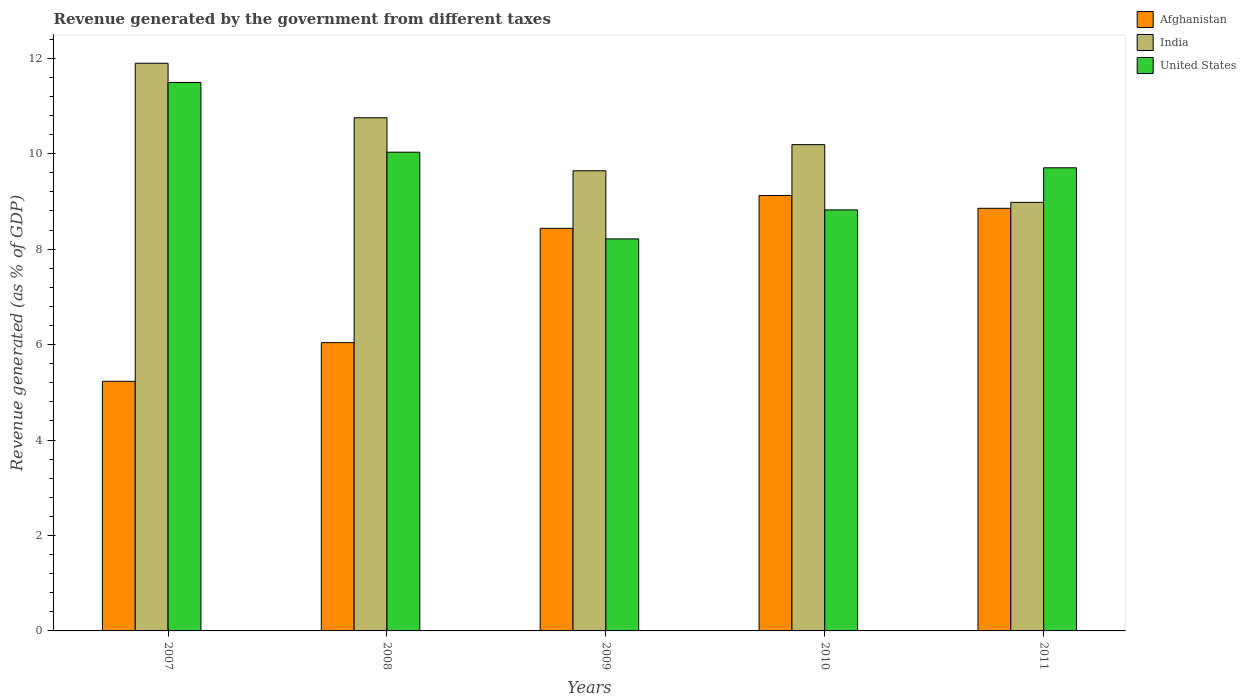How many different coloured bars are there?
Your response must be concise. 3. How many groups of bars are there?
Ensure brevity in your answer.  5. How many bars are there on the 2nd tick from the left?
Make the answer very short. 3. How many bars are there on the 1st tick from the right?
Provide a short and direct response. 3. What is the label of the 2nd group of bars from the left?
Offer a very short reply. 2008. In how many cases, is the number of bars for a given year not equal to the number of legend labels?
Make the answer very short. 0. What is the revenue generated by the government in Afghanistan in 2011?
Make the answer very short. 8.85. Across all years, what is the maximum revenue generated by the government in India?
Your answer should be very brief. 11.89. Across all years, what is the minimum revenue generated by the government in United States?
Provide a succinct answer. 8.21. What is the total revenue generated by the government in Afghanistan in the graph?
Provide a succinct answer. 37.68. What is the difference between the revenue generated by the government in United States in 2008 and that in 2009?
Your answer should be compact. 1.82. What is the difference between the revenue generated by the government in United States in 2008 and the revenue generated by the government in India in 2009?
Give a very brief answer. 0.39. What is the average revenue generated by the government in India per year?
Keep it short and to the point. 10.29. In the year 2010, what is the difference between the revenue generated by the government in Afghanistan and revenue generated by the government in India?
Keep it short and to the point. -1.06. What is the ratio of the revenue generated by the government in Afghanistan in 2010 to that in 2011?
Offer a very short reply. 1.03. Is the revenue generated by the government in Afghanistan in 2007 less than that in 2011?
Make the answer very short. Yes. Is the difference between the revenue generated by the government in Afghanistan in 2007 and 2009 greater than the difference between the revenue generated by the government in India in 2007 and 2009?
Offer a terse response. No. What is the difference between the highest and the second highest revenue generated by the government in Afghanistan?
Ensure brevity in your answer.  0.27. What is the difference between the highest and the lowest revenue generated by the government in Afghanistan?
Offer a very short reply. 3.89. Is it the case that in every year, the sum of the revenue generated by the government in United States and revenue generated by the government in India is greater than the revenue generated by the government in Afghanistan?
Provide a short and direct response. Yes. How many bars are there?
Keep it short and to the point. 15. How many years are there in the graph?
Provide a succinct answer. 5. Does the graph contain any zero values?
Ensure brevity in your answer.  No. Does the graph contain grids?
Provide a short and direct response. No. How are the legend labels stacked?
Your response must be concise. Vertical. What is the title of the graph?
Make the answer very short. Revenue generated by the government from different taxes. What is the label or title of the Y-axis?
Make the answer very short. Revenue generated (as % of GDP). What is the Revenue generated (as % of GDP) in Afghanistan in 2007?
Ensure brevity in your answer.  5.23. What is the Revenue generated (as % of GDP) of India in 2007?
Your answer should be compact. 11.89. What is the Revenue generated (as % of GDP) of United States in 2007?
Make the answer very short. 11.49. What is the Revenue generated (as % of GDP) of Afghanistan in 2008?
Give a very brief answer. 6.04. What is the Revenue generated (as % of GDP) of India in 2008?
Make the answer very short. 10.75. What is the Revenue generated (as % of GDP) in United States in 2008?
Provide a succinct answer. 10.03. What is the Revenue generated (as % of GDP) of Afghanistan in 2009?
Ensure brevity in your answer.  8.43. What is the Revenue generated (as % of GDP) in India in 2009?
Your answer should be very brief. 9.64. What is the Revenue generated (as % of GDP) in United States in 2009?
Your answer should be very brief. 8.21. What is the Revenue generated (as % of GDP) in Afghanistan in 2010?
Offer a terse response. 9.12. What is the Revenue generated (as % of GDP) of India in 2010?
Provide a succinct answer. 10.19. What is the Revenue generated (as % of GDP) in United States in 2010?
Offer a terse response. 8.82. What is the Revenue generated (as % of GDP) of Afghanistan in 2011?
Offer a terse response. 8.85. What is the Revenue generated (as % of GDP) of India in 2011?
Keep it short and to the point. 8.98. What is the Revenue generated (as % of GDP) in United States in 2011?
Offer a very short reply. 9.7. Across all years, what is the maximum Revenue generated (as % of GDP) of Afghanistan?
Provide a short and direct response. 9.12. Across all years, what is the maximum Revenue generated (as % of GDP) in India?
Make the answer very short. 11.89. Across all years, what is the maximum Revenue generated (as % of GDP) of United States?
Your response must be concise. 11.49. Across all years, what is the minimum Revenue generated (as % of GDP) of Afghanistan?
Your answer should be very brief. 5.23. Across all years, what is the minimum Revenue generated (as % of GDP) of India?
Your response must be concise. 8.98. Across all years, what is the minimum Revenue generated (as % of GDP) of United States?
Provide a succinct answer. 8.21. What is the total Revenue generated (as % of GDP) in Afghanistan in the graph?
Offer a terse response. 37.68. What is the total Revenue generated (as % of GDP) of India in the graph?
Make the answer very short. 51.45. What is the total Revenue generated (as % of GDP) in United States in the graph?
Ensure brevity in your answer.  48.26. What is the difference between the Revenue generated (as % of GDP) in Afghanistan in 2007 and that in 2008?
Your answer should be very brief. -0.81. What is the difference between the Revenue generated (as % of GDP) of India in 2007 and that in 2008?
Provide a short and direct response. 1.14. What is the difference between the Revenue generated (as % of GDP) in United States in 2007 and that in 2008?
Give a very brief answer. 1.46. What is the difference between the Revenue generated (as % of GDP) of Afghanistan in 2007 and that in 2009?
Ensure brevity in your answer.  -3.21. What is the difference between the Revenue generated (as % of GDP) of India in 2007 and that in 2009?
Provide a short and direct response. 2.25. What is the difference between the Revenue generated (as % of GDP) in United States in 2007 and that in 2009?
Give a very brief answer. 3.28. What is the difference between the Revenue generated (as % of GDP) of Afghanistan in 2007 and that in 2010?
Provide a short and direct response. -3.89. What is the difference between the Revenue generated (as % of GDP) of India in 2007 and that in 2010?
Give a very brief answer. 1.71. What is the difference between the Revenue generated (as % of GDP) in United States in 2007 and that in 2010?
Provide a short and direct response. 2.67. What is the difference between the Revenue generated (as % of GDP) in Afghanistan in 2007 and that in 2011?
Give a very brief answer. -3.62. What is the difference between the Revenue generated (as % of GDP) of India in 2007 and that in 2011?
Give a very brief answer. 2.91. What is the difference between the Revenue generated (as % of GDP) of United States in 2007 and that in 2011?
Give a very brief answer. 1.79. What is the difference between the Revenue generated (as % of GDP) in Afghanistan in 2008 and that in 2009?
Offer a terse response. -2.4. What is the difference between the Revenue generated (as % of GDP) of India in 2008 and that in 2009?
Your response must be concise. 1.11. What is the difference between the Revenue generated (as % of GDP) of United States in 2008 and that in 2009?
Your answer should be very brief. 1.82. What is the difference between the Revenue generated (as % of GDP) in Afghanistan in 2008 and that in 2010?
Your answer should be compact. -3.08. What is the difference between the Revenue generated (as % of GDP) in India in 2008 and that in 2010?
Offer a terse response. 0.56. What is the difference between the Revenue generated (as % of GDP) of United States in 2008 and that in 2010?
Provide a succinct answer. 1.21. What is the difference between the Revenue generated (as % of GDP) in Afghanistan in 2008 and that in 2011?
Make the answer very short. -2.82. What is the difference between the Revenue generated (as % of GDP) of India in 2008 and that in 2011?
Your answer should be compact. 1.77. What is the difference between the Revenue generated (as % of GDP) in United States in 2008 and that in 2011?
Give a very brief answer. 0.33. What is the difference between the Revenue generated (as % of GDP) in Afghanistan in 2009 and that in 2010?
Keep it short and to the point. -0.69. What is the difference between the Revenue generated (as % of GDP) in India in 2009 and that in 2010?
Your answer should be compact. -0.55. What is the difference between the Revenue generated (as % of GDP) of United States in 2009 and that in 2010?
Your answer should be very brief. -0.61. What is the difference between the Revenue generated (as % of GDP) in Afghanistan in 2009 and that in 2011?
Offer a very short reply. -0.42. What is the difference between the Revenue generated (as % of GDP) of India in 2009 and that in 2011?
Keep it short and to the point. 0.66. What is the difference between the Revenue generated (as % of GDP) of United States in 2009 and that in 2011?
Provide a succinct answer. -1.49. What is the difference between the Revenue generated (as % of GDP) of Afghanistan in 2010 and that in 2011?
Offer a very short reply. 0.27. What is the difference between the Revenue generated (as % of GDP) of India in 2010 and that in 2011?
Ensure brevity in your answer.  1.21. What is the difference between the Revenue generated (as % of GDP) in United States in 2010 and that in 2011?
Give a very brief answer. -0.88. What is the difference between the Revenue generated (as % of GDP) in Afghanistan in 2007 and the Revenue generated (as % of GDP) in India in 2008?
Make the answer very short. -5.52. What is the difference between the Revenue generated (as % of GDP) of Afghanistan in 2007 and the Revenue generated (as % of GDP) of United States in 2008?
Your answer should be compact. -4.8. What is the difference between the Revenue generated (as % of GDP) of India in 2007 and the Revenue generated (as % of GDP) of United States in 2008?
Make the answer very short. 1.86. What is the difference between the Revenue generated (as % of GDP) of Afghanistan in 2007 and the Revenue generated (as % of GDP) of India in 2009?
Make the answer very short. -4.41. What is the difference between the Revenue generated (as % of GDP) in Afghanistan in 2007 and the Revenue generated (as % of GDP) in United States in 2009?
Ensure brevity in your answer.  -2.98. What is the difference between the Revenue generated (as % of GDP) in India in 2007 and the Revenue generated (as % of GDP) in United States in 2009?
Your answer should be very brief. 3.68. What is the difference between the Revenue generated (as % of GDP) in Afghanistan in 2007 and the Revenue generated (as % of GDP) in India in 2010?
Give a very brief answer. -4.96. What is the difference between the Revenue generated (as % of GDP) in Afghanistan in 2007 and the Revenue generated (as % of GDP) in United States in 2010?
Your answer should be very brief. -3.59. What is the difference between the Revenue generated (as % of GDP) in India in 2007 and the Revenue generated (as % of GDP) in United States in 2010?
Provide a short and direct response. 3.07. What is the difference between the Revenue generated (as % of GDP) in Afghanistan in 2007 and the Revenue generated (as % of GDP) in India in 2011?
Your answer should be compact. -3.75. What is the difference between the Revenue generated (as % of GDP) of Afghanistan in 2007 and the Revenue generated (as % of GDP) of United States in 2011?
Your response must be concise. -4.47. What is the difference between the Revenue generated (as % of GDP) of India in 2007 and the Revenue generated (as % of GDP) of United States in 2011?
Your answer should be compact. 2.19. What is the difference between the Revenue generated (as % of GDP) of Afghanistan in 2008 and the Revenue generated (as % of GDP) of India in 2009?
Ensure brevity in your answer.  -3.6. What is the difference between the Revenue generated (as % of GDP) of Afghanistan in 2008 and the Revenue generated (as % of GDP) of United States in 2009?
Provide a succinct answer. -2.17. What is the difference between the Revenue generated (as % of GDP) in India in 2008 and the Revenue generated (as % of GDP) in United States in 2009?
Your answer should be compact. 2.54. What is the difference between the Revenue generated (as % of GDP) of Afghanistan in 2008 and the Revenue generated (as % of GDP) of India in 2010?
Ensure brevity in your answer.  -4.15. What is the difference between the Revenue generated (as % of GDP) of Afghanistan in 2008 and the Revenue generated (as % of GDP) of United States in 2010?
Give a very brief answer. -2.78. What is the difference between the Revenue generated (as % of GDP) of India in 2008 and the Revenue generated (as % of GDP) of United States in 2010?
Offer a very short reply. 1.93. What is the difference between the Revenue generated (as % of GDP) of Afghanistan in 2008 and the Revenue generated (as % of GDP) of India in 2011?
Ensure brevity in your answer.  -2.94. What is the difference between the Revenue generated (as % of GDP) in Afghanistan in 2008 and the Revenue generated (as % of GDP) in United States in 2011?
Make the answer very short. -3.66. What is the difference between the Revenue generated (as % of GDP) in India in 2008 and the Revenue generated (as % of GDP) in United States in 2011?
Your response must be concise. 1.05. What is the difference between the Revenue generated (as % of GDP) of Afghanistan in 2009 and the Revenue generated (as % of GDP) of India in 2010?
Ensure brevity in your answer.  -1.75. What is the difference between the Revenue generated (as % of GDP) in Afghanistan in 2009 and the Revenue generated (as % of GDP) in United States in 2010?
Offer a very short reply. -0.39. What is the difference between the Revenue generated (as % of GDP) of India in 2009 and the Revenue generated (as % of GDP) of United States in 2010?
Your answer should be very brief. 0.82. What is the difference between the Revenue generated (as % of GDP) in Afghanistan in 2009 and the Revenue generated (as % of GDP) in India in 2011?
Make the answer very short. -0.54. What is the difference between the Revenue generated (as % of GDP) of Afghanistan in 2009 and the Revenue generated (as % of GDP) of United States in 2011?
Your answer should be compact. -1.27. What is the difference between the Revenue generated (as % of GDP) of India in 2009 and the Revenue generated (as % of GDP) of United States in 2011?
Ensure brevity in your answer.  -0.06. What is the difference between the Revenue generated (as % of GDP) in Afghanistan in 2010 and the Revenue generated (as % of GDP) in India in 2011?
Your response must be concise. 0.14. What is the difference between the Revenue generated (as % of GDP) in Afghanistan in 2010 and the Revenue generated (as % of GDP) in United States in 2011?
Your answer should be compact. -0.58. What is the difference between the Revenue generated (as % of GDP) of India in 2010 and the Revenue generated (as % of GDP) of United States in 2011?
Ensure brevity in your answer.  0.48. What is the average Revenue generated (as % of GDP) in Afghanistan per year?
Provide a succinct answer. 7.54. What is the average Revenue generated (as % of GDP) in India per year?
Ensure brevity in your answer.  10.29. What is the average Revenue generated (as % of GDP) in United States per year?
Provide a succinct answer. 9.65. In the year 2007, what is the difference between the Revenue generated (as % of GDP) in Afghanistan and Revenue generated (as % of GDP) in India?
Provide a succinct answer. -6.66. In the year 2007, what is the difference between the Revenue generated (as % of GDP) of Afghanistan and Revenue generated (as % of GDP) of United States?
Your response must be concise. -6.26. In the year 2007, what is the difference between the Revenue generated (as % of GDP) in India and Revenue generated (as % of GDP) in United States?
Your answer should be compact. 0.4. In the year 2008, what is the difference between the Revenue generated (as % of GDP) in Afghanistan and Revenue generated (as % of GDP) in India?
Give a very brief answer. -4.71. In the year 2008, what is the difference between the Revenue generated (as % of GDP) of Afghanistan and Revenue generated (as % of GDP) of United States?
Offer a terse response. -3.99. In the year 2008, what is the difference between the Revenue generated (as % of GDP) of India and Revenue generated (as % of GDP) of United States?
Provide a short and direct response. 0.72. In the year 2009, what is the difference between the Revenue generated (as % of GDP) of Afghanistan and Revenue generated (as % of GDP) of India?
Give a very brief answer. -1.21. In the year 2009, what is the difference between the Revenue generated (as % of GDP) in Afghanistan and Revenue generated (as % of GDP) in United States?
Provide a succinct answer. 0.22. In the year 2009, what is the difference between the Revenue generated (as % of GDP) in India and Revenue generated (as % of GDP) in United States?
Provide a short and direct response. 1.43. In the year 2010, what is the difference between the Revenue generated (as % of GDP) of Afghanistan and Revenue generated (as % of GDP) of India?
Your response must be concise. -1.06. In the year 2010, what is the difference between the Revenue generated (as % of GDP) in Afghanistan and Revenue generated (as % of GDP) in United States?
Ensure brevity in your answer.  0.3. In the year 2010, what is the difference between the Revenue generated (as % of GDP) of India and Revenue generated (as % of GDP) of United States?
Your answer should be very brief. 1.37. In the year 2011, what is the difference between the Revenue generated (as % of GDP) in Afghanistan and Revenue generated (as % of GDP) in India?
Make the answer very short. -0.12. In the year 2011, what is the difference between the Revenue generated (as % of GDP) of Afghanistan and Revenue generated (as % of GDP) of United States?
Provide a succinct answer. -0.85. In the year 2011, what is the difference between the Revenue generated (as % of GDP) in India and Revenue generated (as % of GDP) in United States?
Make the answer very short. -0.72. What is the ratio of the Revenue generated (as % of GDP) of Afghanistan in 2007 to that in 2008?
Provide a succinct answer. 0.87. What is the ratio of the Revenue generated (as % of GDP) in India in 2007 to that in 2008?
Provide a succinct answer. 1.11. What is the ratio of the Revenue generated (as % of GDP) of United States in 2007 to that in 2008?
Offer a very short reply. 1.15. What is the ratio of the Revenue generated (as % of GDP) in Afghanistan in 2007 to that in 2009?
Offer a terse response. 0.62. What is the ratio of the Revenue generated (as % of GDP) of India in 2007 to that in 2009?
Your answer should be compact. 1.23. What is the ratio of the Revenue generated (as % of GDP) of United States in 2007 to that in 2009?
Make the answer very short. 1.4. What is the ratio of the Revenue generated (as % of GDP) in Afghanistan in 2007 to that in 2010?
Give a very brief answer. 0.57. What is the ratio of the Revenue generated (as % of GDP) in India in 2007 to that in 2010?
Your response must be concise. 1.17. What is the ratio of the Revenue generated (as % of GDP) in United States in 2007 to that in 2010?
Your response must be concise. 1.3. What is the ratio of the Revenue generated (as % of GDP) of Afghanistan in 2007 to that in 2011?
Offer a terse response. 0.59. What is the ratio of the Revenue generated (as % of GDP) of India in 2007 to that in 2011?
Provide a succinct answer. 1.32. What is the ratio of the Revenue generated (as % of GDP) of United States in 2007 to that in 2011?
Your answer should be compact. 1.18. What is the ratio of the Revenue generated (as % of GDP) of Afghanistan in 2008 to that in 2009?
Provide a succinct answer. 0.72. What is the ratio of the Revenue generated (as % of GDP) in India in 2008 to that in 2009?
Give a very brief answer. 1.12. What is the ratio of the Revenue generated (as % of GDP) in United States in 2008 to that in 2009?
Make the answer very short. 1.22. What is the ratio of the Revenue generated (as % of GDP) in Afghanistan in 2008 to that in 2010?
Provide a short and direct response. 0.66. What is the ratio of the Revenue generated (as % of GDP) of India in 2008 to that in 2010?
Offer a terse response. 1.06. What is the ratio of the Revenue generated (as % of GDP) of United States in 2008 to that in 2010?
Your response must be concise. 1.14. What is the ratio of the Revenue generated (as % of GDP) in Afghanistan in 2008 to that in 2011?
Make the answer very short. 0.68. What is the ratio of the Revenue generated (as % of GDP) of India in 2008 to that in 2011?
Offer a very short reply. 1.2. What is the ratio of the Revenue generated (as % of GDP) in United States in 2008 to that in 2011?
Give a very brief answer. 1.03. What is the ratio of the Revenue generated (as % of GDP) of Afghanistan in 2009 to that in 2010?
Your response must be concise. 0.92. What is the ratio of the Revenue generated (as % of GDP) of India in 2009 to that in 2010?
Offer a terse response. 0.95. What is the ratio of the Revenue generated (as % of GDP) of United States in 2009 to that in 2010?
Offer a very short reply. 0.93. What is the ratio of the Revenue generated (as % of GDP) of Afghanistan in 2009 to that in 2011?
Offer a terse response. 0.95. What is the ratio of the Revenue generated (as % of GDP) of India in 2009 to that in 2011?
Keep it short and to the point. 1.07. What is the ratio of the Revenue generated (as % of GDP) in United States in 2009 to that in 2011?
Ensure brevity in your answer.  0.85. What is the ratio of the Revenue generated (as % of GDP) of Afghanistan in 2010 to that in 2011?
Provide a succinct answer. 1.03. What is the ratio of the Revenue generated (as % of GDP) in India in 2010 to that in 2011?
Offer a terse response. 1.13. What is the ratio of the Revenue generated (as % of GDP) in United States in 2010 to that in 2011?
Offer a terse response. 0.91. What is the difference between the highest and the second highest Revenue generated (as % of GDP) of Afghanistan?
Provide a short and direct response. 0.27. What is the difference between the highest and the second highest Revenue generated (as % of GDP) in India?
Give a very brief answer. 1.14. What is the difference between the highest and the second highest Revenue generated (as % of GDP) of United States?
Provide a succinct answer. 1.46. What is the difference between the highest and the lowest Revenue generated (as % of GDP) of Afghanistan?
Provide a succinct answer. 3.89. What is the difference between the highest and the lowest Revenue generated (as % of GDP) of India?
Provide a short and direct response. 2.91. What is the difference between the highest and the lowest Revenue generated (as % of GDP) in United States?
Ensure brevity in your answer.  3.28. 